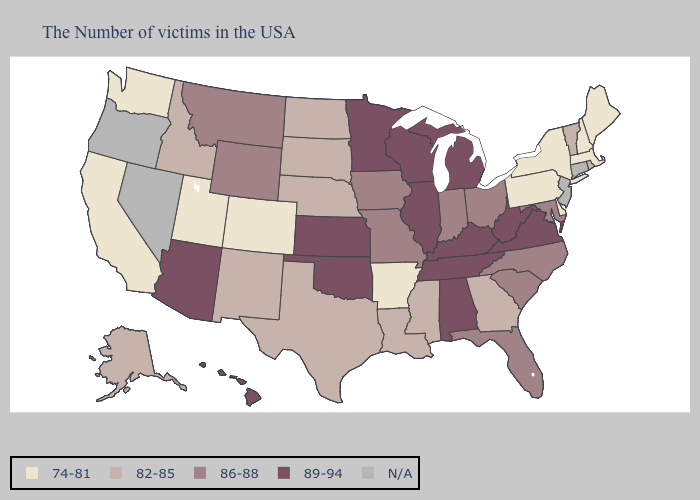What is the value of Arizona?
Write a very short answer. 89-94. Does Montana have the lowest value in the USA?
Answer briefly. No. Name the states that have a value in the range 82-85?
Give a very brief answer. Rhode Island, Vermont, Georgia, Mississippi, Louisiana, Nebraska, Texas, South Dakota, North Dakota, New Mexico, Idaho, Alaska. Name the states that have a value in the range N/A?
Be succinct. Connecticut, New Jersey, Nevada, Oregon. Does Hawaii have the lowest value in the West?
Give a very brief answer. No. Name the states that have a value in the range 89-94?
Keep it brief. Virginia, West Virginia, Michigan, Kentucky, Alabama, Tennessee, Wisconsin, Illinois, Minnesota, Kansas, Oklahoma, Arizona, Hawaii. Does California have the lowest value in the USA?
Be succinct. Yes. Name the states that have a value in the range 86-88?
Be succinct. Maryland, North Carolina, South Carolina, Ohio, Florida, Indiana, Missouri, Iowa, Wyoming, Montana. What is the lowest value in the Northeast?
Concise answer only. 74-81. What is the highest value in states that border Arizona?
Quick response, please. 82-85. Does the first symbol in the legend represent the smallest category?
Write a very short answer. Yes. Among the states that border New York , which have the lowest value?
Concise answer only. Massachusetts, Pennsylvania. Name the states that have a value in the range 86-88?
Write a very short answer. Maryland, North Carolina, South Carolina, Ohio, Florida, Indiana, Missouri, Iowa, Wyoming, Montana. 